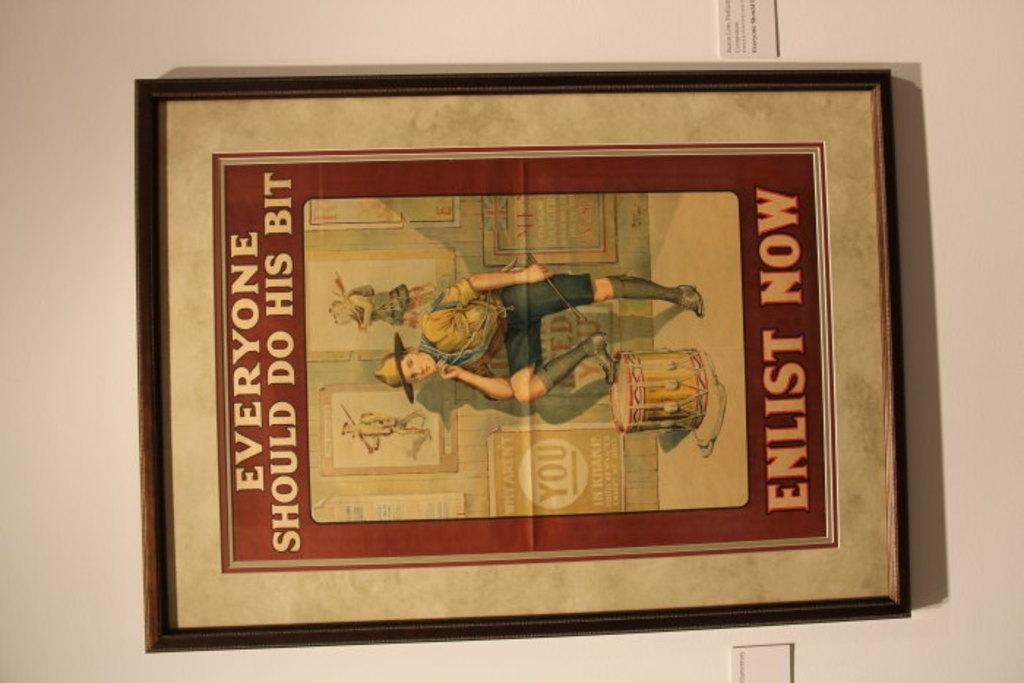Provide a one-sentence caption for the provided image. Picture of everyone should do his bit enlist now. 